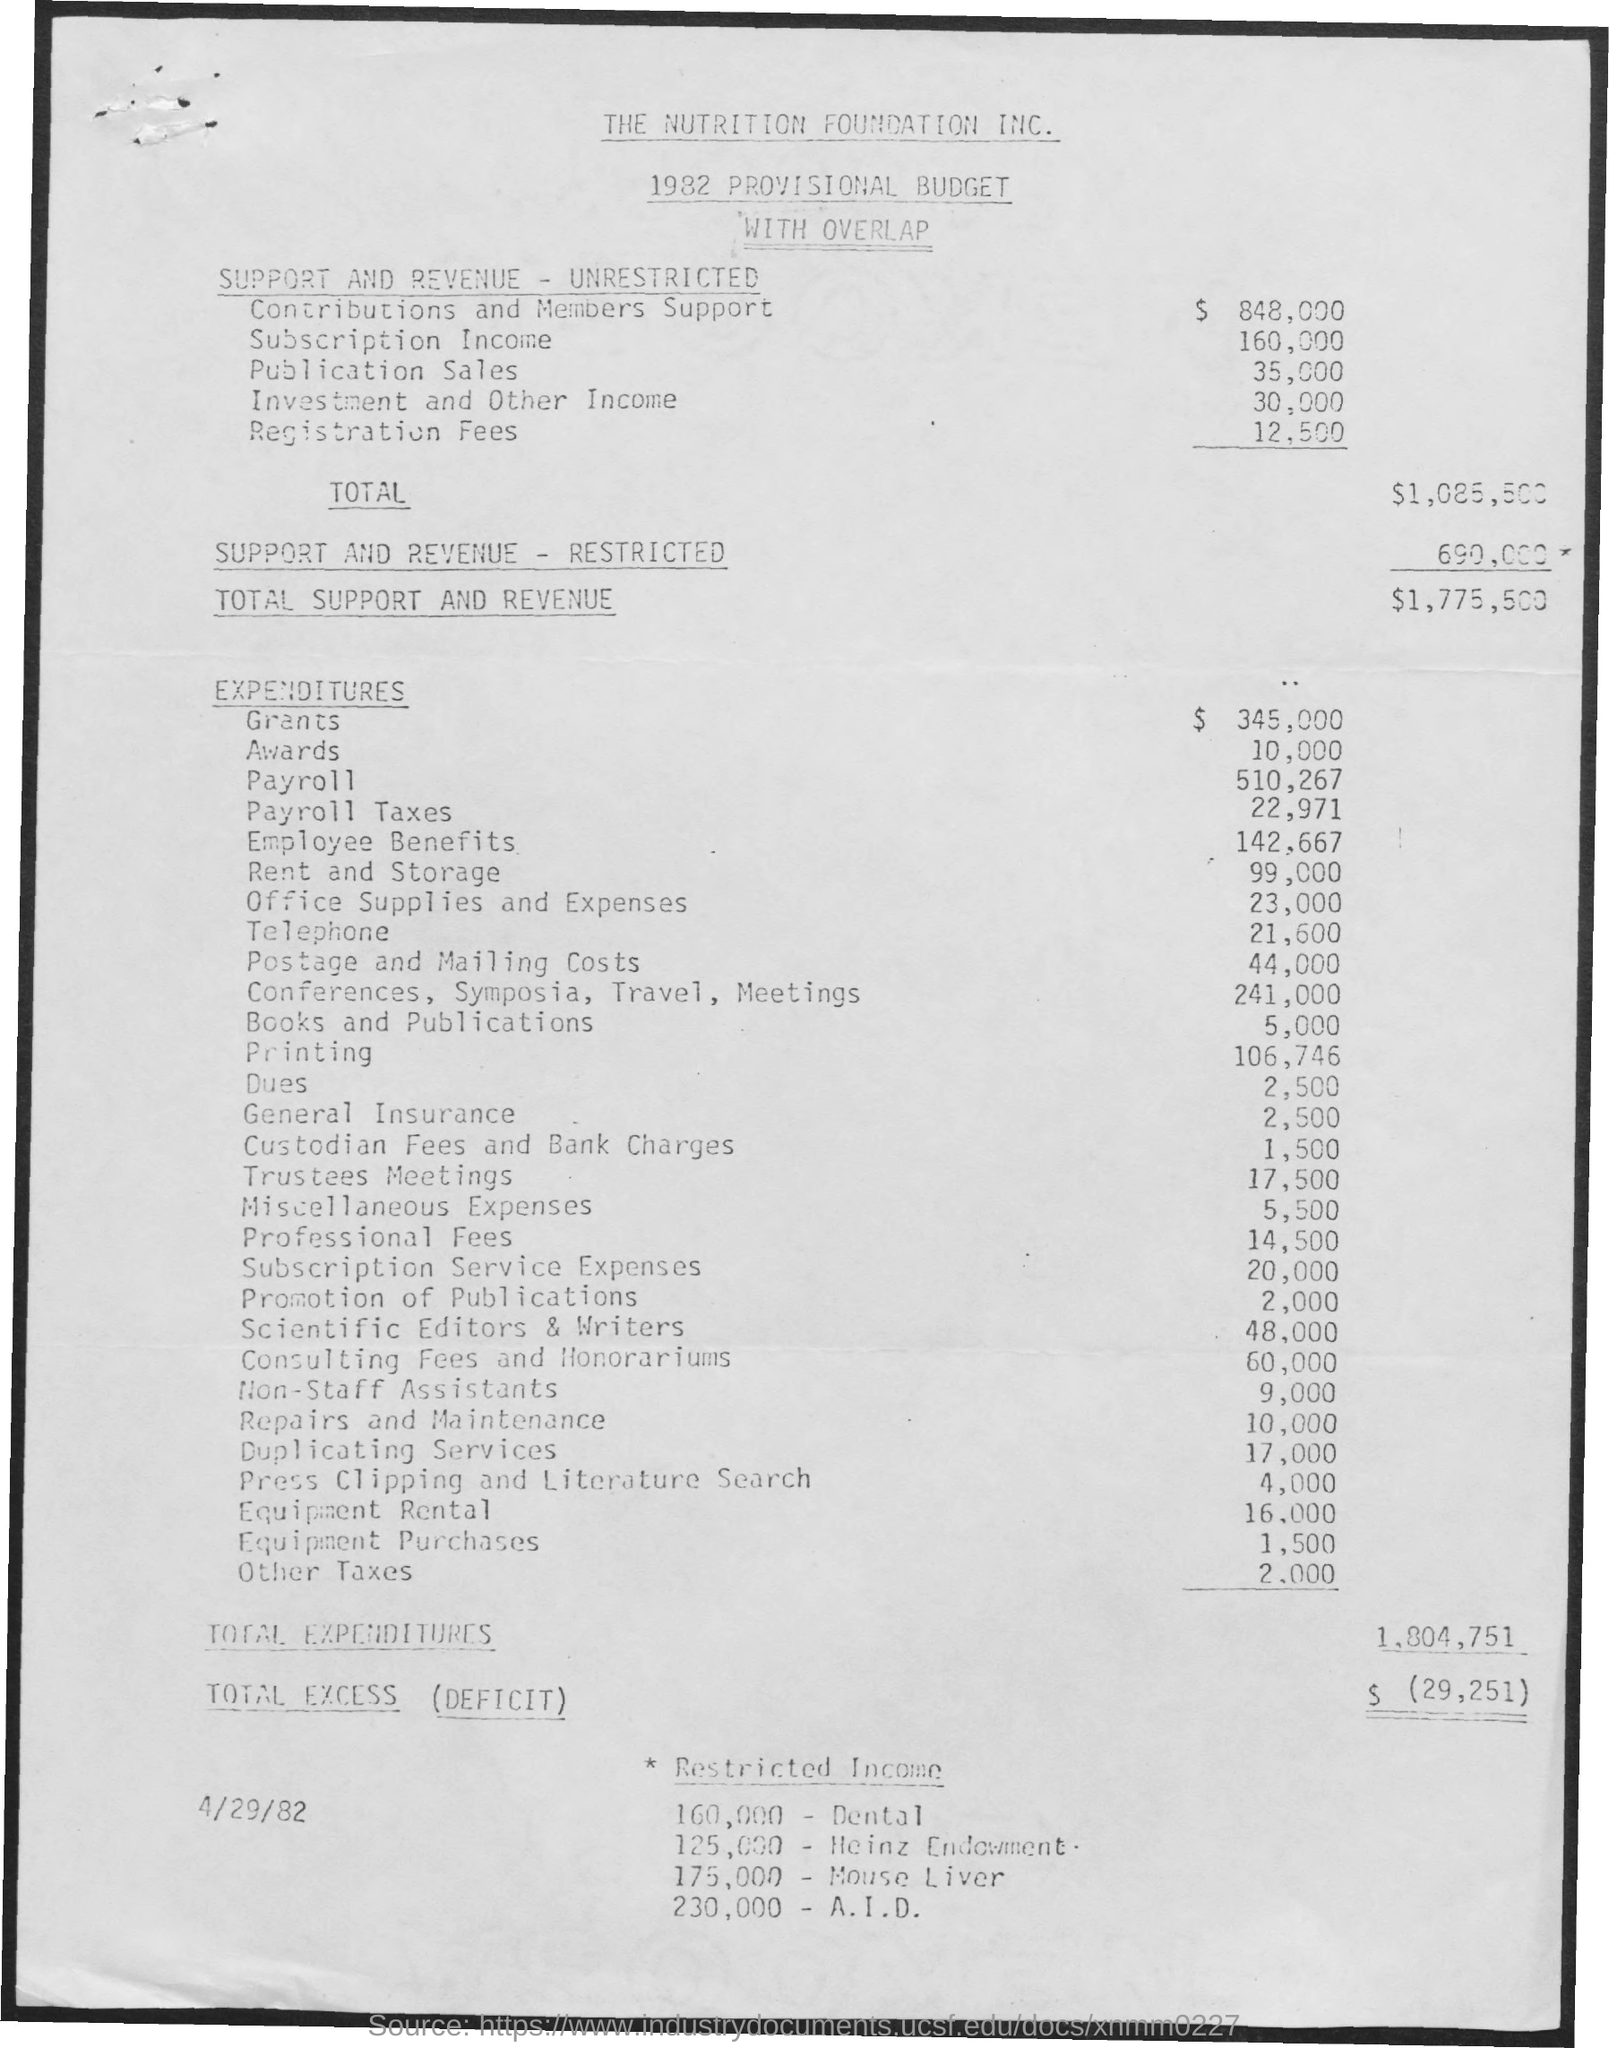What is the first title in the document?
Ensure brevity in your answer.  The Nutrition Foundation, Inc. What is the second title in the document?
Provide a short and direct response. 1982 Provisional Budget with Overlap. What is the total Expenditure?
Your response must be concise. 1,804,751. What is the date mentioned in the document?
Provide a short and direct response. 4/29/82. What is the total support and revenue?
Offer a terse response. 1,775,500. What is the cost of printing?
Your answer should be compact. 106,746. 